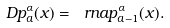<formula> <loc_0><loc_0><loc_500><loc_500>\ D p _ { a } ^ { \alpha } ( x ) = \ r n { a } p _ { a - 1 } ^ { \alpha } ( x ) .</formula> 